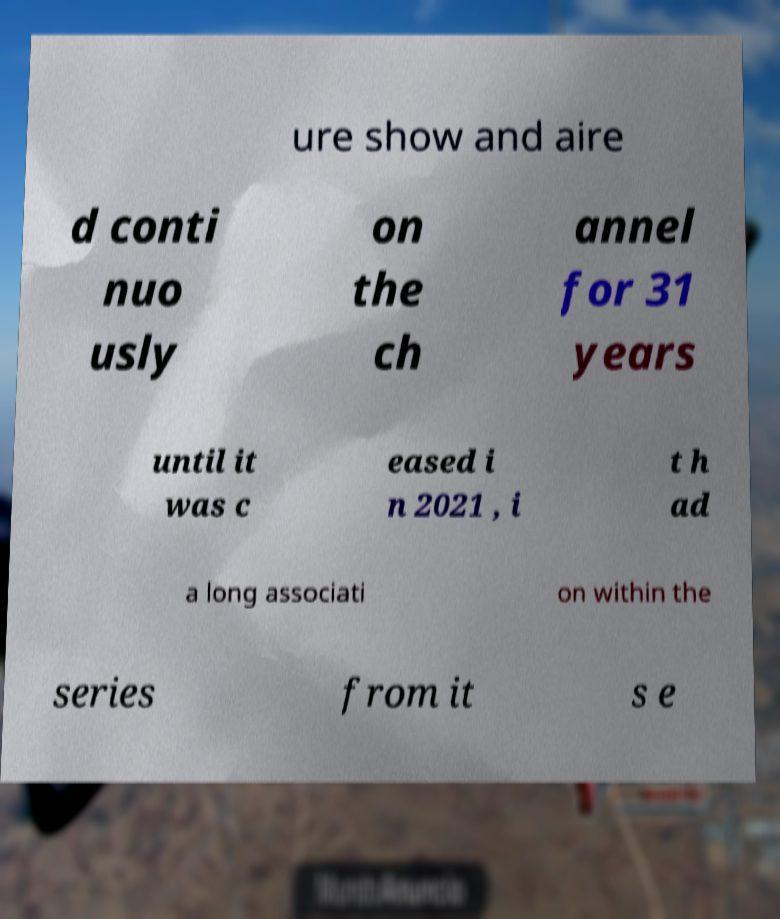Could you extract and type out the text from this image? ure show and aire d conti nuo usly on the ch annel for 31 years until it was c eased i n 2021 , i t h ad a long associati on within the series from it s e 